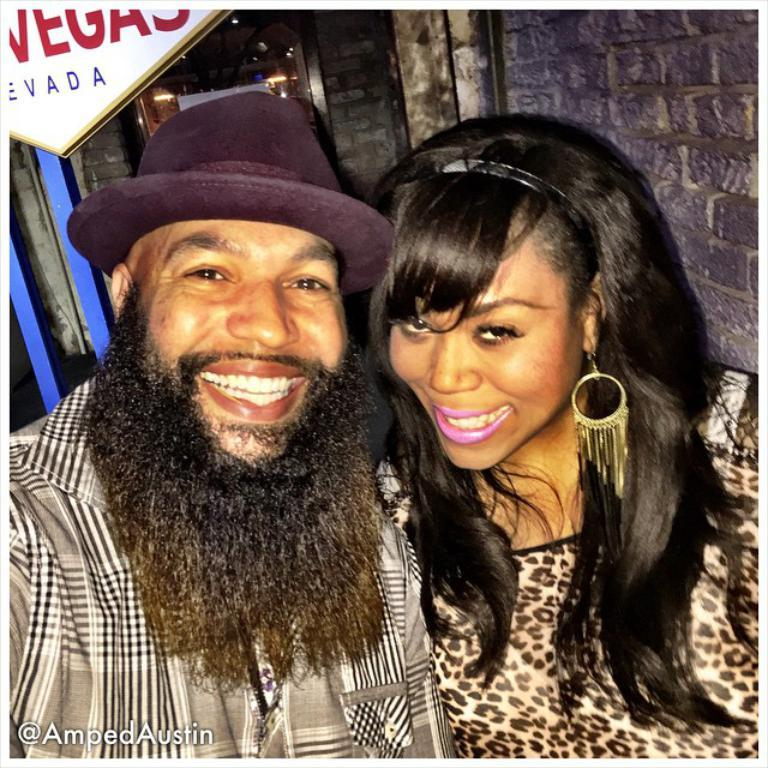Who is present in the image? There is a couple in the image. What are the couple doing in the image? The couple is sitting in the front and giving a pose to the camera. What is the couple's facial expression in the image? The couple is smiling in the image. What can be seen in the background of the image? There is a brick wall and a notice board in the background of the image. What type of comb is the couple using in the image? There is no comb present in the image. Can you tell me how many bats are flying in the background of the image? There are no bats present in the image; only a brick wall and a notice board can be seen in the background. 